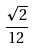<formula> <loc_0><loc_0><loc_500><loc_500>\frac { \sqrt { 2 } } { 1 2 }</formula> 